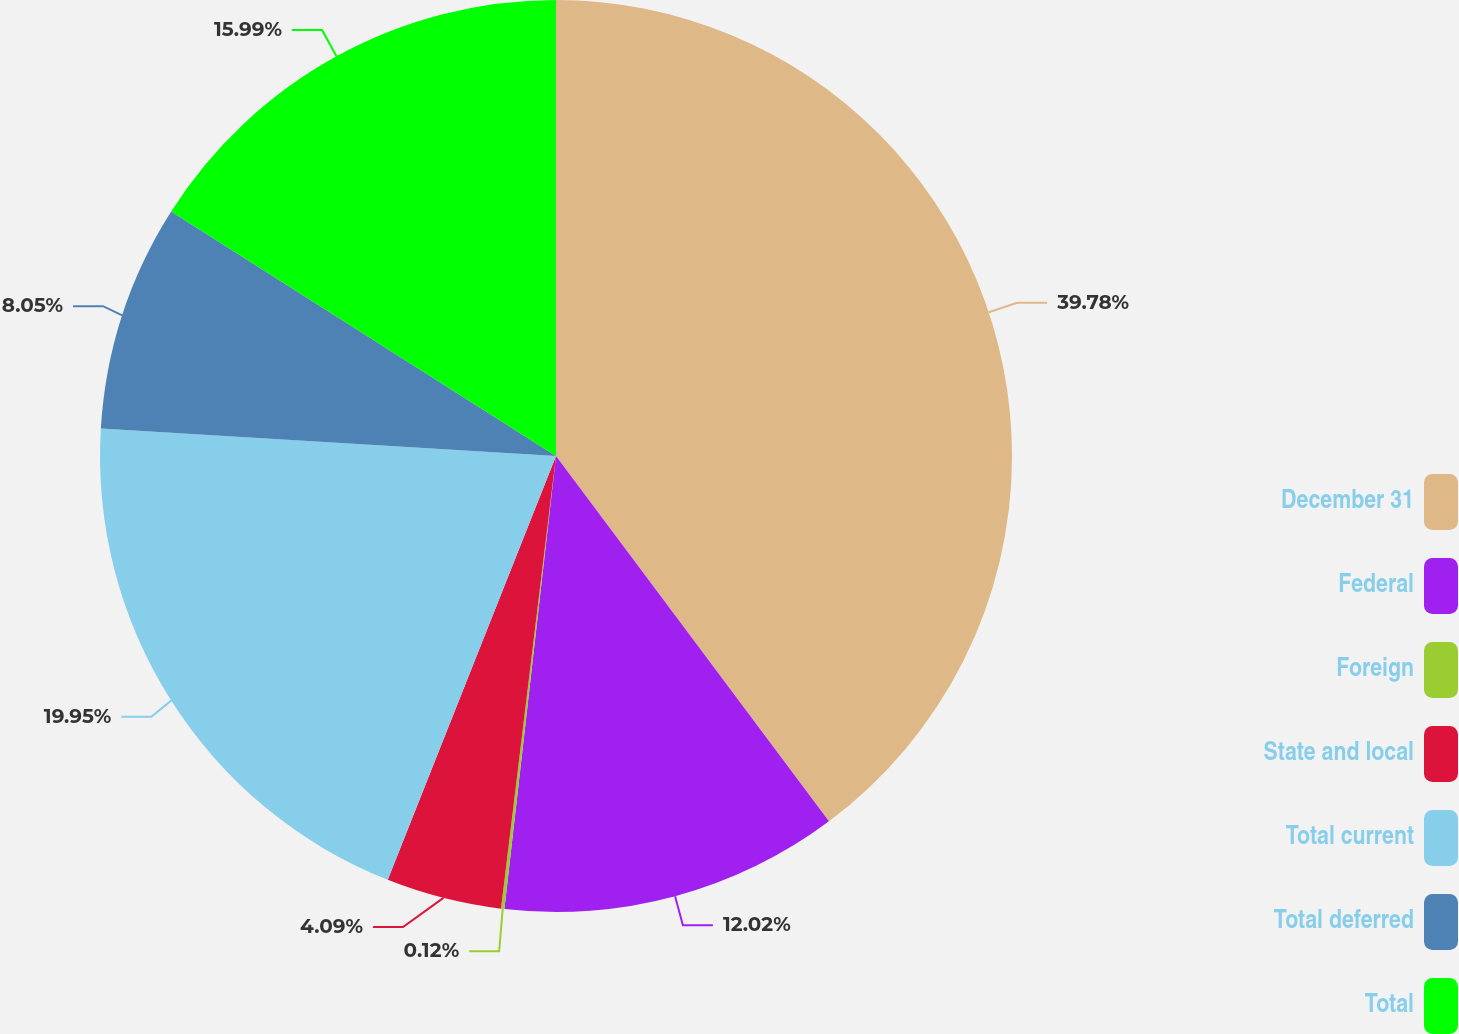Convert chart. <chart><loc_0><loc_0><loc_500><loc_500><pie_chart><fcel>December 31<fcel>Federal<fcel>Foreign<fcel>State and local<fcel>Total current<fcel>Total deferred<fcel>Total<nl><fcel>39.79%<fcel>12.02%<fcel>0.12%<fcel>4.09%<fcel>19.95%<fcel>8.05%<fcel>15.99%<nl></chart> 